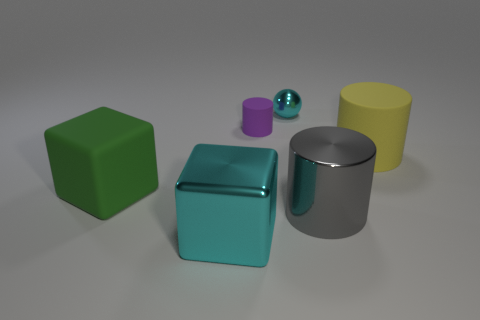Does the small purple cylinder have the same material as the small cyan sphere?
Your response must be concise. No. There is a shiny object that is to the right of the big metallic block and in front of the tiny matte cylinder; what color is it?
Keep it short and to the point. Gray. What is the size of the yellow cylinder behind the metal thing that is on the right side of the small shiny ball?
Offer a very short reply. Large. Do the metal ball and the small cylinder have the same color?
Your answer should be very brief. No. The cyan cube is what size?
Keep it short and to the point. Large. How many tiny metal spheres are the same color as the small shiny thing?
Offer a very short reply. 0. There is a rubber object left of the big metal object that is in front of the large gray shiny cylinder; is there a cylinder that is to the left of it?
Offer a terse response. No. What shape is the rubber object that is the same size as the green cube?
Provide a succinct answer. Cylinder. How many tiny objects are either metal cylinders or purple rubber cylinders?
Your answer should be compact. 1. There is a cylinder that is the same material as the purple object; what is its color?
Offer a very short reply. Yellow. 